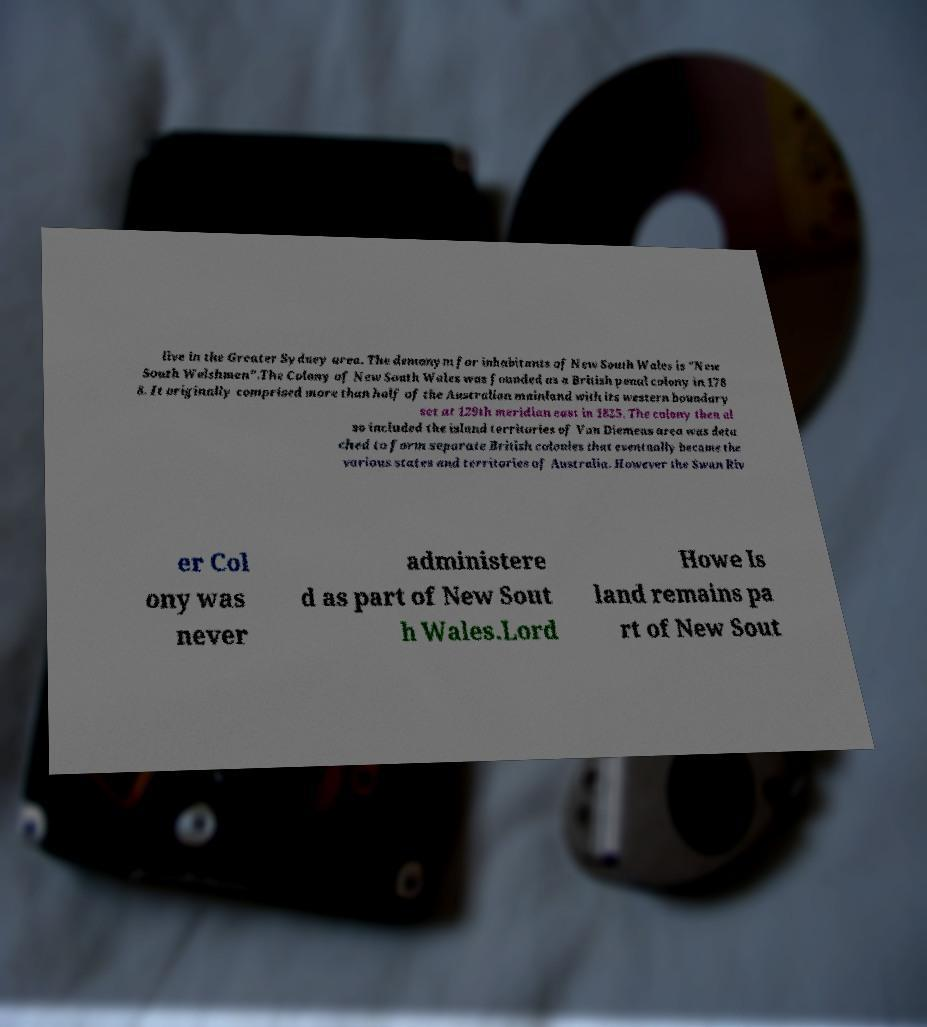Could you extract and type out the text from this image? live in the Greater Sydney area. The demonym for inhabitants of New South Wales is "New South Welshmen".The Colony of New South Wales was founded as a British penal colony in 178 8. It originally comprised more than half of the Australian mainland with its western boundary set at 129th meridian east in 1825. The colony then al so included the island territories of Van Diemens area was deta ched to form separate British colonies that eventually became the various states and territories of Australia. However the Swan Riv er Col ony was never administere d as part of New Sout h Wales.Lord Howe Is land remains pa rt of New Sout 